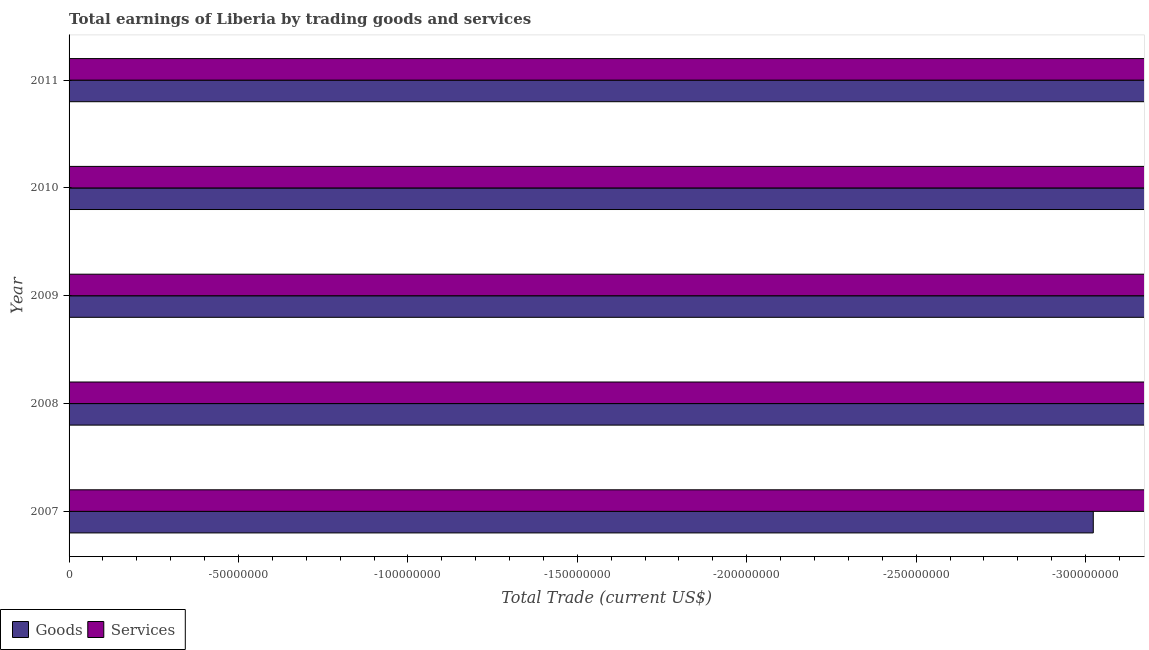How many different coloured bars are there?
Provide a short and direct response. 0. Are the number of bars per tick equal to the number of legend labels?
Keep it short and to the point. No. In how many years, is the amount earned by trading goods greater than -210000000 US$?
Ensure brevity in your answer.  0. In how many years, is the amount earned by trading services greater than the average amount earned by trading services taken over all years?
Give a very brief answer. 0. How many bars are there?
Offer a very short reply. 0. What is the difference between two consecutive major ticks on the X-axis?
Offer a very short reply. 5.00e+07. Does the graph contain grids?
Provide a succinct answer. No. Where does the legend appear in the graph?
Provide a succinct answer. Bottom left. How are the legend labels stacked?
Your response must be concise. Horizontal. What is the title of the graph?
Your response must be concise. Total earnings of Liberia by trading goods and services. What is the label or title of the X-axis?
Ensure brevity in your answer.  Total Trade (current US$). What is the label or title of the Y-axis?
Your answer should be compact. Year. What is the Total Trade (current US$) in Services in 2008?
Give a very brief answer. 0. What is the Total Trade (current US$) in Goods in 2009?
Offer a terse response. 0. What is the Total Trade (current US$) in Services in 2009?
Offer a very short reply. 0. What is the Total Trade (current US$) in Goods in 2011?
Offer a very short reply. 0. What is the total Total Trade (current US$) in Services in the graph?
Your response must be concise. 0. 